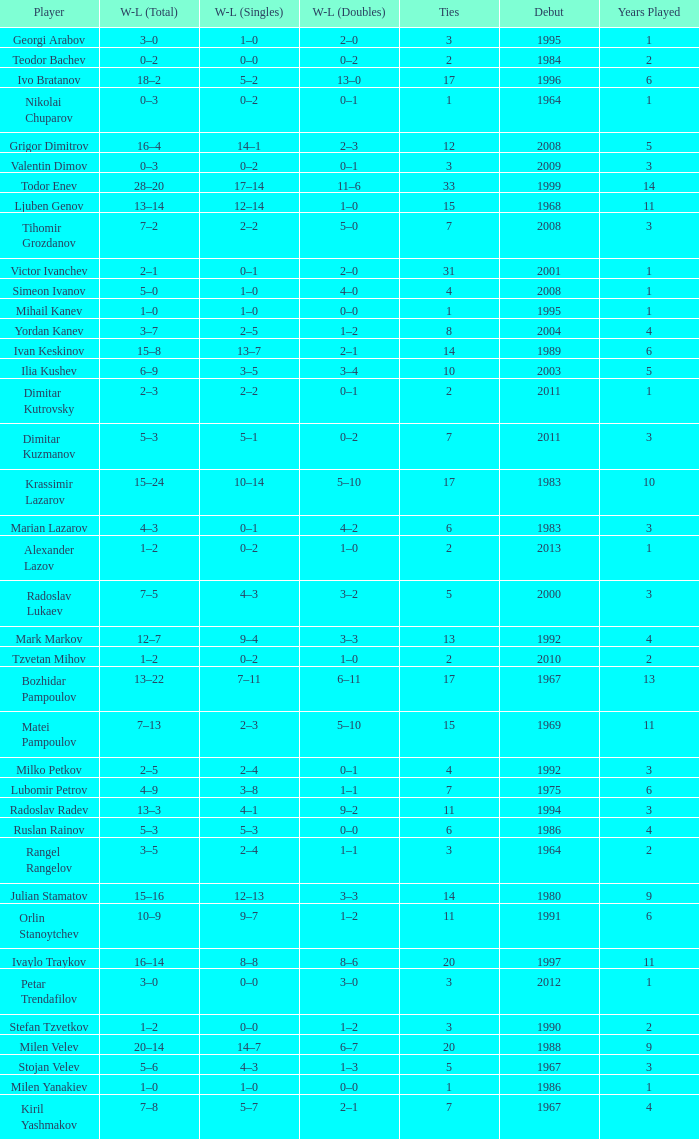Tell me the WL doubles with a debut of 1999 11–6. 